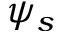<formula> <loc_0><loc_0><loc_500><loc_500>\psi _ { s }</formula> 